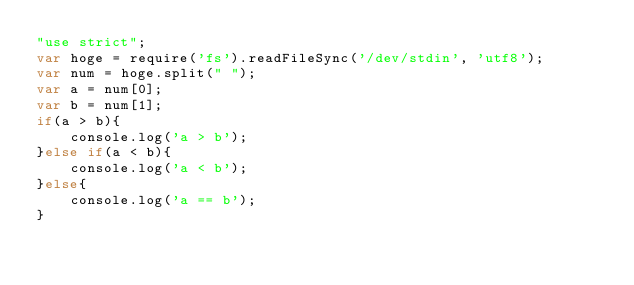<code> <loc_0><loc_0><loc_500><loc_500><_JavaScript_>"use strict";
var hoge = require('fs').readFileSync('/dev/stdin', 'utf8');
var num = hoge.split(" ");
var a = num[0];
var b = num[1];
if(a > b){
    console.log('a > b');
}else if(a < b){
    console.log('a < b');
}else{
    console.log('a == b');
}</code> 